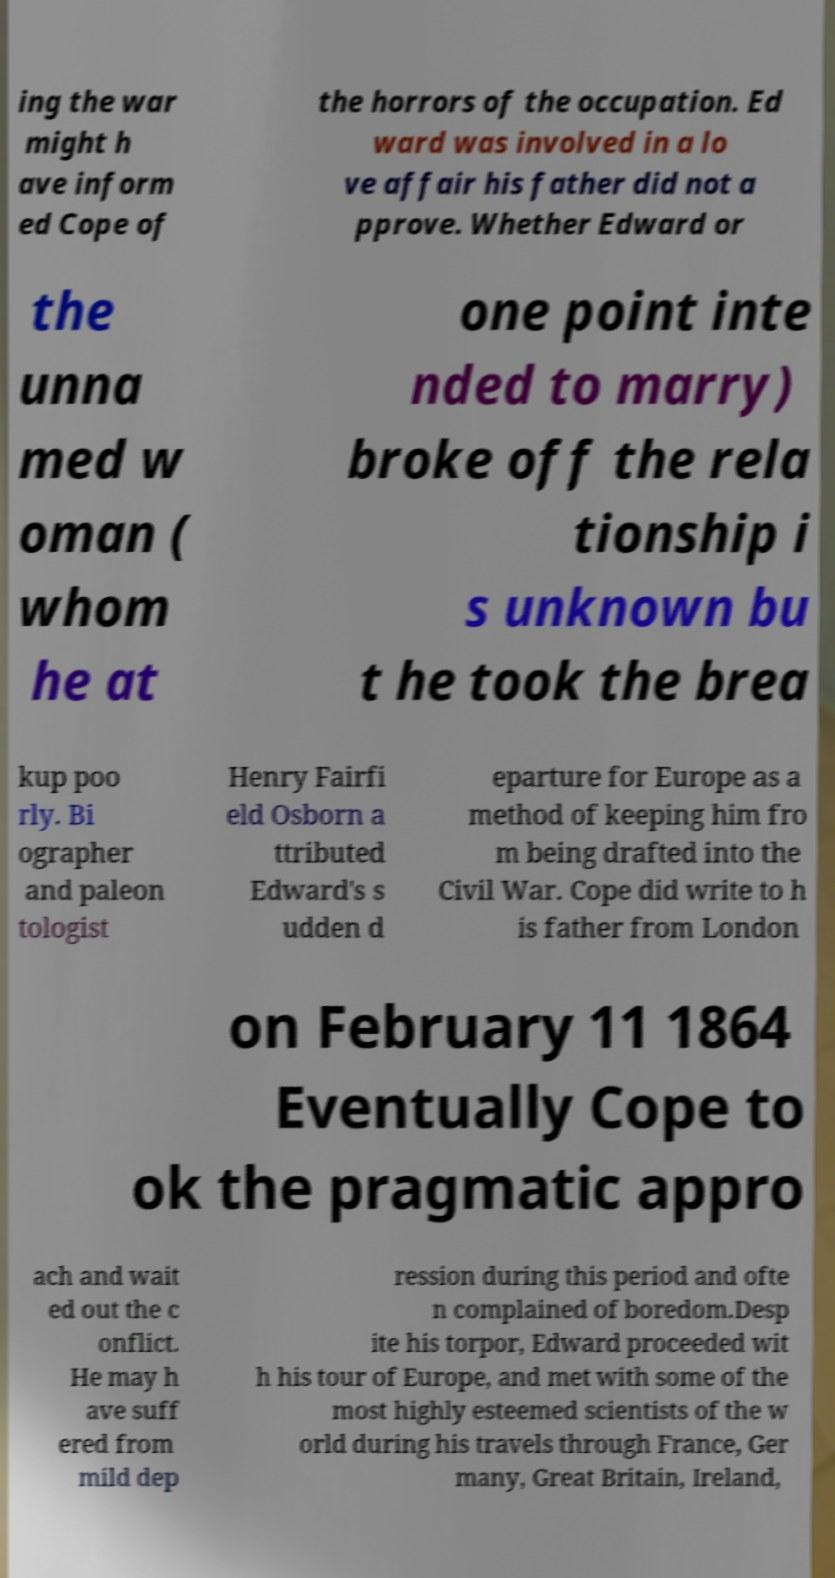For documentation purposes, I need the text within this image transcribed. Could you provide that? ing the war might h ave inform ed Cope of the horrors of the occupation. Ed ward was involved in a lo ve affair his father did not a pprove. Whether Edward or the unna med w oman ( whom he at one point inte nded to marry) broke off the rela tionship i s unknown bu t he took the brea kup poo rly. Bi ographer and paleon tologist Henry Fairfi eld Osborn a ttributed Edward's s udden d eparture for Europe as a method of keeping him fro m being drafted into the Civil War. Cope did write to h is father from London on February 11 1864 Eventually Cope to ok the pragmatic appro ach and wait ed out the c onflict. He may h ave suff ered from mild dep ression during this period and ofte n complained of boredom.Desp ite his torpor, Edward proceeded wit h his tour of Europe, and met with some of the most highly esteemed scientists of the w orld during his travels through France, Ger many, Great Britain, Ireland, 